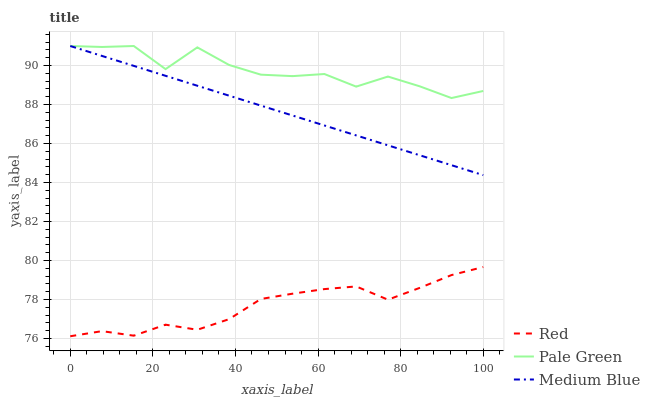Does Red have the minimum area under the curve?
Answer yes or no. Yes. Does Pale Green have the maximum area under the curve?
Answer yes or no. Yes. Does Medium Blue have the minimum area under the curve?
Answer yes or no. No. Does Medium Blue have the maximum area under the curve?
Answer yes or no. No. Is Medium Blue the smoothest?
Answer yes or no. Yes. Is Pale Green the roughest?
Answer yes or no. Yes. Is Red the smoothest?
Answer yes or no. No. Is Red the roughest?
Answer yes or no. No. Does Red have the lowest value?
Answer yes or no. Yes. Does Medium Blue have the lowest value?
Answer yes or no. No. Does Medium Blue have the highest value?
Answer yes or no. Yes. Does Red have the highest value?
Answer yes or no. No. Is Red less than Medium Blue?
Answer yes or no. Yes. Is Medium Blue greater than Red?
Answer yes or no. Yes. Does Medium Blue intersect Pale Green?
Answer yes or no. Yes. Is Medium Blue less than Pale Green?
Answer yes or no. No. Is Medium Blue greater than Pale Green?
Answer yes or no. No. Does Red intersect Medium Blue?
Answer yes or no. No. 